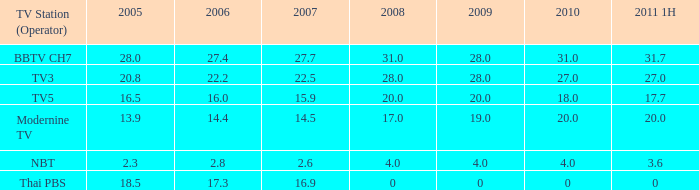How many 2011 1h values contain a 2006 of 2 0.0. 